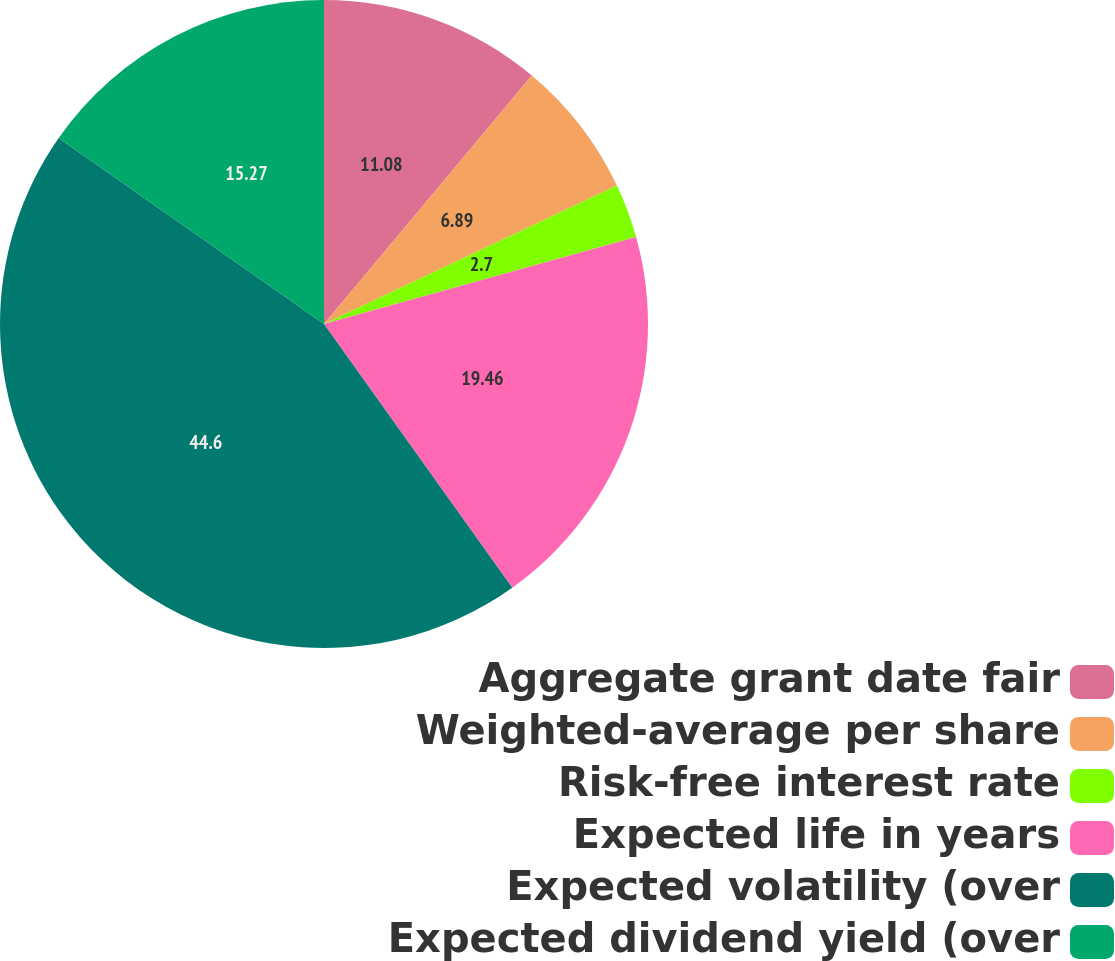<chart> <loc_0><loc_0><loc_500><loc_500><pie_chart><fcel>Aggregate grant date fair<fcel>Weighted-average per share<fcel>Risk-free interest rate<fcel>Expected life in years<fcel>Expected volatility (over<fcel>Expected dividend yield (over<nl><fcel>11.08%<fcel>6.89%<fcel>2.7%<fcel>19.46%<fcel>44.6%<fcel>15.27%<nl></chart> 